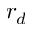<formula> <loc_0><loc_0><loc_500><loc_500>r _ { d }</formula> 